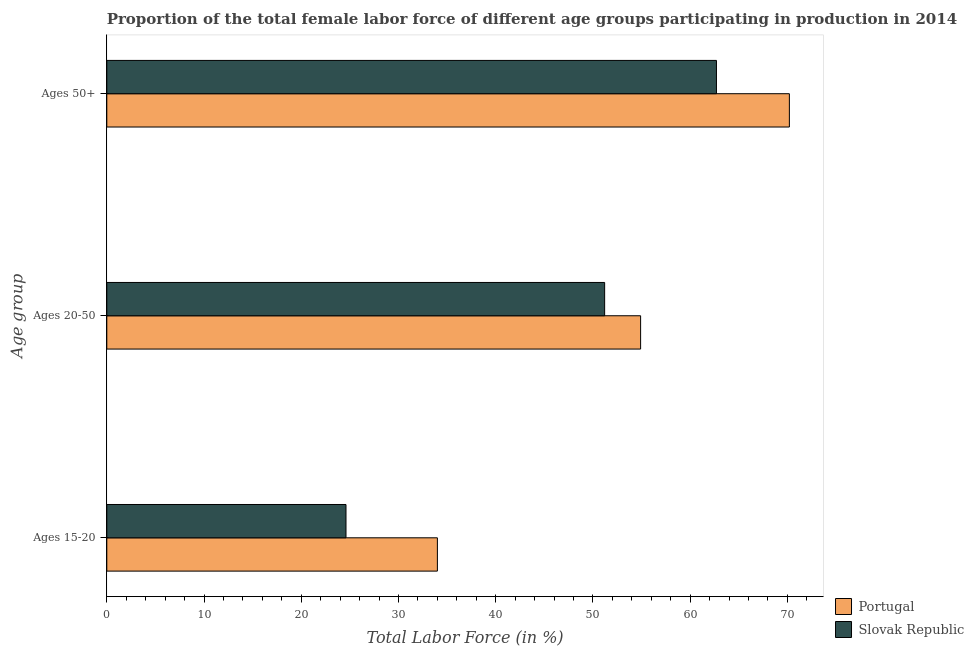How many groups of bars are there?
Ensure brevity in your answer.  3. Are the number of bars per tick equal to the number of legend labels?
Give a very brief answer. Yes. Are the number of bars on each tick of the Y-axis equal?
Provide a short and direct response. Yes. How many bars are there on the 2nd tick from the top?
Keep it short and to the point. 2. What is the label of the 3rd group of bars from the top?
Keep it short and to the point. Ages 15-20. What is the percentage of female labor force within the age group 15-20 in Slovak Republic?
Your response must be concise. 24.6. Across all countries, what is the maximum percentage of female labor force above age 50?
Ensure brevity in your answer.  70.2. Across all countries, what is the minimum percentage of female labor force above age 50?
Your response must be concise. 62.7. In which country was the percentage of female labor force within the age group 20-50 minimum?
Give a very brief answer. Slovak Republic. What is the total percentage of female labor force above age 50 in the graph?
Give a very brief answer. 132.9. What is the difference between the percentage of female labor force above age 50 in Portugal and that in Slovak Republic?
Ensure brevity in your answer.  7.5. What is the difference between the percentage of female labor force above age 50 in Slovak Republic and the percentage of female labor force within the age group 15-20 in Portugal?
Ensure brevity in your answer.  28.7. What is the average percentage of female labor force within the age group 15-20 per country?
Keep it short and to the point. 29.3. What is the difference between the percentage of female labor force within the age group 20-50 and percentage of female labor force above age 50 in Portugal?
Offer a very short reply. -15.3. In how many countries, is the percentage of female labor force above age 50 greater than 54 %?
Ensure brevity in your answer.  2. What is the ratio of the percentage of female labor force above age 50 in Portugal to that in Slovak Republic?
Offer a terse response. 1.12. Is the percentage of female labor force above age 50 in Slovak Republic less than that in Portugal?
Offer a terse response. Yes. Is the difference between the percentage of female labor force within the age group 15-20 in Slovak Republic and Portugal greater than the difference between the percentage of female labor force within the age group 20-50 in Slovak Republic and Portugal?
Your answer should be very brief. No. What is the difference between the highest and the second highest percentage of female labor force within the age group 20-50?
Ensure brevity in your answer.  3.7. What is the difference between the highest and the lowest percentage of female labor force within the age group 20-50?
Your answer should be compact. 3.7. In how many countries, is the percentage of female labor force above age 50 greater than the average percentage of female labor force above age 50 taken over all countries?
Provide a short and direct response. 1. What does the 1st bar from the bottom in Ages 50+ represents?
Offer a terse response. Portugal. How many bars are there?
Offer a very short reply. 6. Are all the bars in the graph horizontal?
Ensure brevity in your answer.  Yes. How many countries are there in the graph?
Ensure brevity in your answer.  2. Where does the legend appear in the graph?
Ensure brevity in your answer.  Bottom right. What is the title of the graph?
Give a very brief answer. Proportion of the total female labor force of different age groups participating in production in 2014. Does "Tonga" appear as one of the legend labels in the graph?
Provide a short and direct response. No. What is the label or title of the Y-axis?
Provide a short and direct response. Age group. What is the Total Labor Force (in %) in Portugal in Ages 15-20?
Keep it short and to the point. 34. What is the Total Labor Force (in %) in Slovak Republic in Ages 15-20?
Your answer should be compact. 24.6. What is the Total Labor Force (in %) of Portugal in Ages 20-50?
Your answer should be very brief. 54.9. What is the Total Labor Force (in %) of Slovak Republic in Ages 20-50?
Provide a succinct answer. 51.2. What is the Total Labor Force (in %) of Portugal in Ages 50+?
Your answer should be compact. 70.2. What is the Total Labor Force (in %) of Slovak Republic in Ages 50+?
Your answer should be very brief. 62.7. Across all Age group, what is the maximum Total Labor Force (in %) in Portugal?
Keep it short and to the point. 70.2. Across all Age group, what is the maximum Total Labor Force (in %) of Slovak Republic?
Offer a terse response. 62.7. Across all Age group, what is the minimum Total Labor Force (in %) in Portugal?
Your answer should be very brief. 34. Across all Age group, what is the minimum Total Labor Force (in %) in Slovak Republic?
Your answer should be compact. 24.6. What is the total Total Labor Force (in %) in Portugal in the graph?
Provide a succinct answer. 159.1. What is the total Total Labor Force (in %) in Slovak Republic in the graph?
Your response must be concise. 138.5. What is the difference between the Total Labor Force (in %) in Portugal in Ages 15-20 and that in Ages 20-50?
Offer a very short reply. -20.9. What is the difference between the Total Labor Force (in %) of Slovak Republic in Ages 15-20 and that in Ages 20-50?
Provide a short and direct response. -26.6. What is the difference between the Total Labor Force (in %) of Portugal in Ages 15-20 and that in Ages 50+?
Provide a succinct answer. -36.2. What is the difference between the Total Labor Force (in %) of Slovak Republic in Ages 15-20 and that in Ages 50+?
Your response must be concise. -38.1. What is the difference between the Total Labor Force (in %) in Portugal in Ages 20-50 and that in Ages 50+?
Provide a succinct answer. -15.3. What is the difference between the Total Labor Force (in %) of Slovak Republic in Ages 20-50 and that in Ages 50+?
Offer a very short reply. -11.5. What is the difference between the Total Labor Force (in %) of Portugal in Ages 15-20 and the Total Labor Force (in %) of Slovak Republic in Ages 20-50?
Your answer should be very brief. -17.2. What is the difference between the Total Labor Force (in %) in Portugal in Ages 15-20 and the Total Labor Force (in %) in Slovak Republic in Ages 50+?
Your answer should be very brief. -28.7. What is the average Total Labor Force (in %) in Portugal per Age group?
Offer a terse response. 53.03. What is the average Total Labor Force (in %) of Slovak Republic per Age group?
Provide a short and direct response. 46.17. What is the difference between the Total Labor Force (in %) of Portugal and Total Labor Force (in %) of Slovak Republic in Ages 15-20?
Ensure brevity in your answer.  9.4. What is the difference between the Total Labor Force (in %) of Portugal and Total Labor Force (in %) of Slovak Republic in Ages 50+?
Your answer should be compact. 7.5. What is the ratio of the Total Labor Force (in %) of Portugal in Ages 15-20 to that in Ages 20-50?
Give a very brief answer. 0.62. What is the ratio of the Total Labor Force (in %) in Slovak Republic in Ages 15-20 to that in Ages 20-50?
Keep it short and to the point. 0.48. What is the ratio of the Total Labor Force (in %) in Portugal in Ages 15-20 to that in Ages 50+?
Make the answer very short. 0.48. What is the ratio of the Total Labor Force (in %) in Slovak Republic in Ages 15-20 to that in Ages 50+?
Make the answer very short. 0.39. What is the ratio of the Total Labor Force (in %) in Portugal in Ages 20-50 to that in Ages 50+?
Make the answer very short. 0.78. What is the ratio of the Total Labor Force (in %) of Slovak Republic in Ages 20-50 to that in Ages 50+?
Keep it short and to the point. 0.82. What is the difference between the highest and the second highest Total Labor Force (in %) of Portugal?
Give a very brief answer. 15.3. What is the difference between the highest and the lowest Total Labor Force (in %) of Portugal?
Your answer should be very brief. 36.2. What is the difference between the highest and the lowest Total Labor Force (in %) in Slovak Republic?
Ensure brevity in your answer.  38.1. 